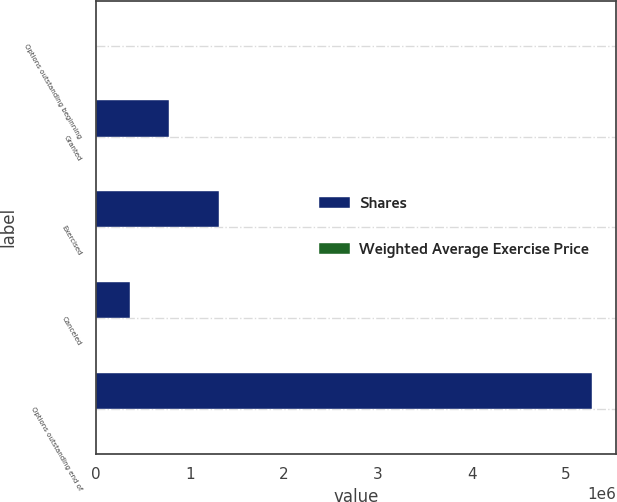Convert chart. <chart><loc_0><loc_0><loc_500><loc_500><stacked_bar_chart><ecel><fcel>Options outstanding beginning<fcel>Granted<fcel>Exercised<fcel>Canceled<fcel>Options outstanding end of<nl><fcel>Shares<fcel>26.41<fcel>775500<fcel>1.31574e+06<fcel>369202<fcel>5.27357e+06<nl><fcel>Weighted Average Exercise Price<fcel>11.78<fcel>26.41<fcel>3.7<fcel>14.07<fcel>15.79<nl></chart> 